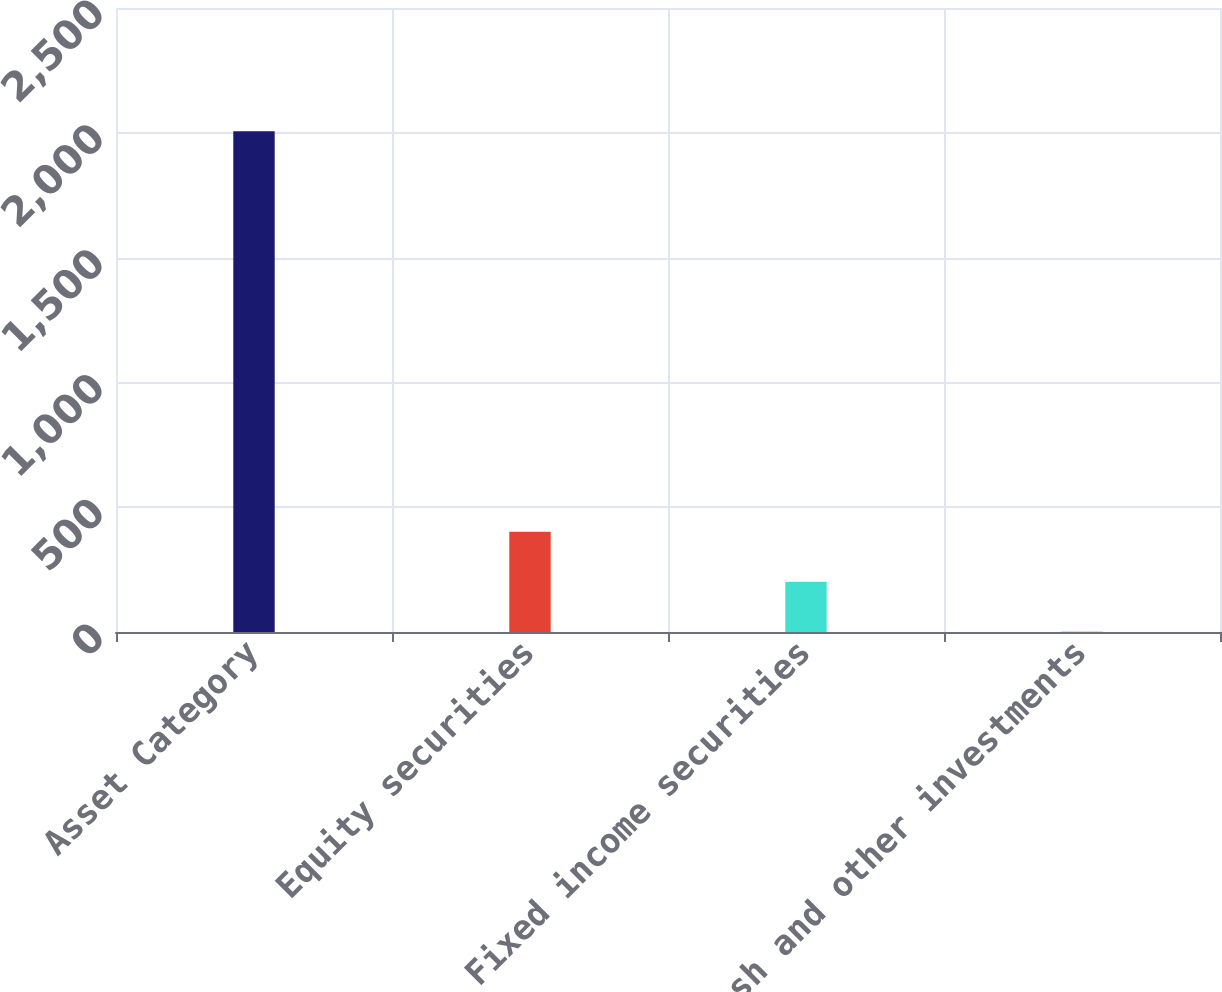<chart> <loc_0><loc_0><loc_500><loc_500><bar_chart><fcel>Asset Category<fcel>Equity securities<fcel>Fixed income securities<fcel>Cash and other investments<nl><fcel>2006<fcel>402<fcel>201.5<fcel>1<nl></chart> 